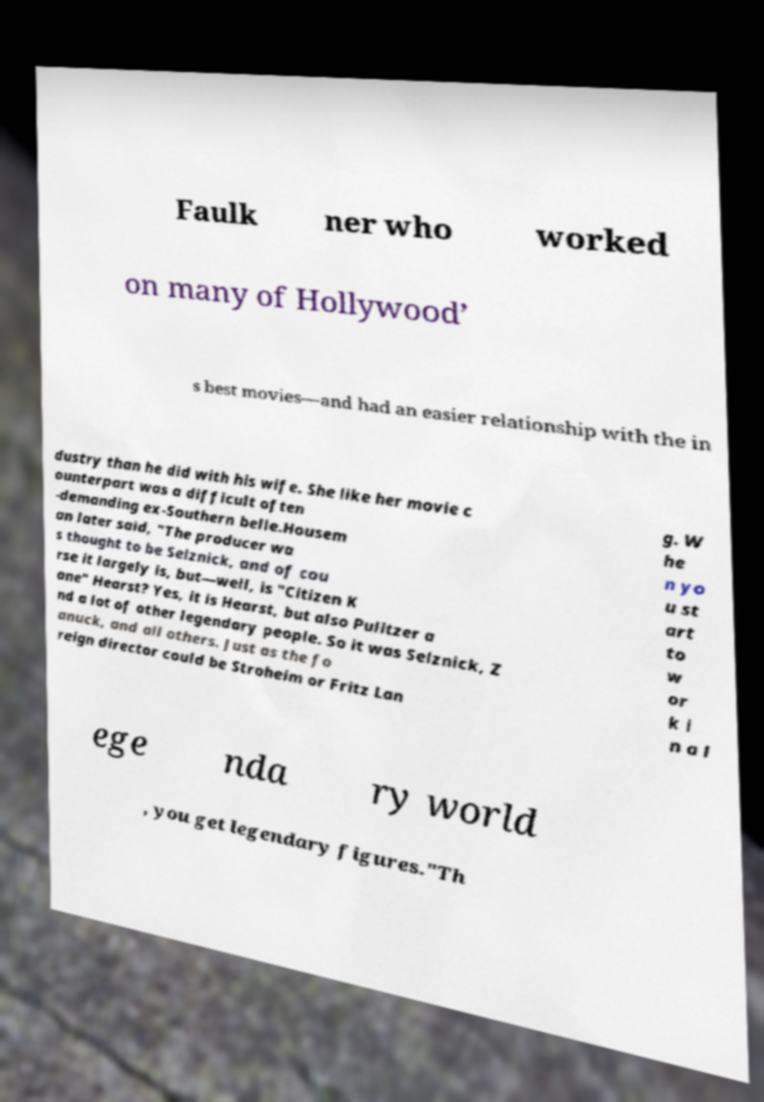Could you extract and type out the text from this image? Faulk ner who worked on many of Hollywood’ s best movies—and had an easier relationship with the in dustry than he did with his wife. She like her movie c ounterpart was a difficult often -demanding ex-Southern belle.Housem an later said, "The producer wa s thought to be Selznick, and of cou rse it largely is, but—well, is "Citizen K ane" Hearst? Yes, it is Hearst, but also Pulitzer a nd a lot of other legendary people. So it was Selznick, Z anuck, and all others. Just as the fo reign director could be Stroheim or Fritz Lan g. W he n yo u st art to w or k i n a l ege nda ry world , you get legendary figures."Th 